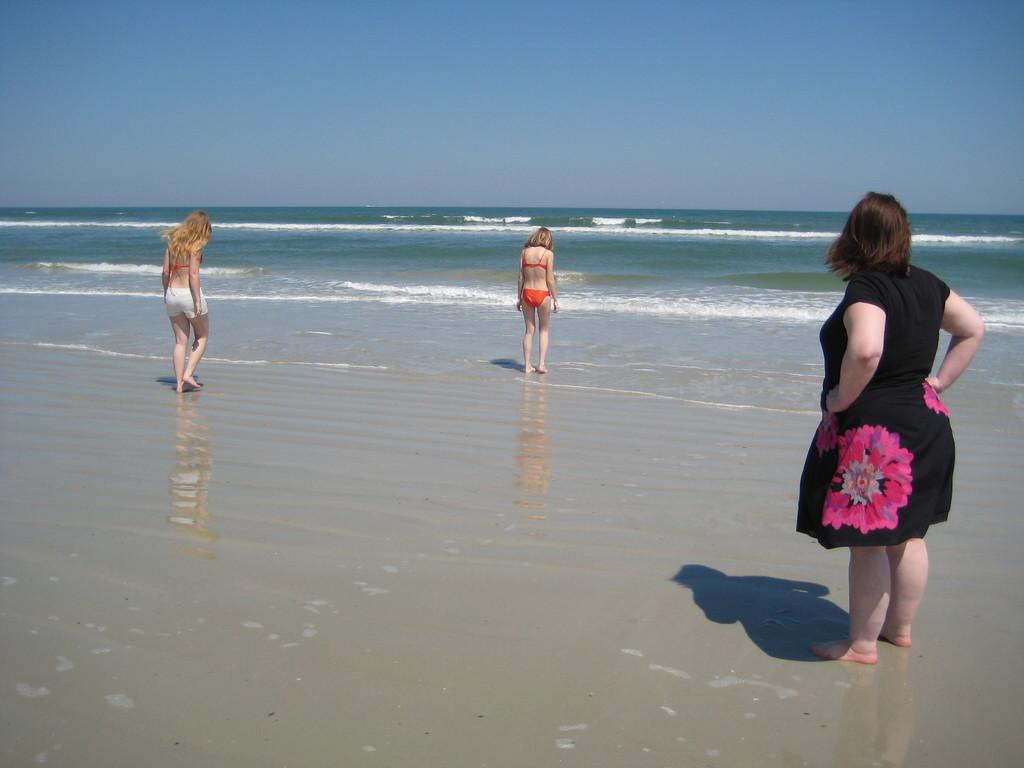What is the location of the image? The image is taken near a beach. How many women are in the image? There are three women in the image. What surface are the women standing on? The women are standing on the sand. What can be seen in front of the women? There are waves in front of the women. What is visible at the top of the image? The sky is visible at the top of the image. What type of camera is being used by the waves in the image? There is no camera present in the image, as the waves are a natural occurrence and not capable of using a camera. 